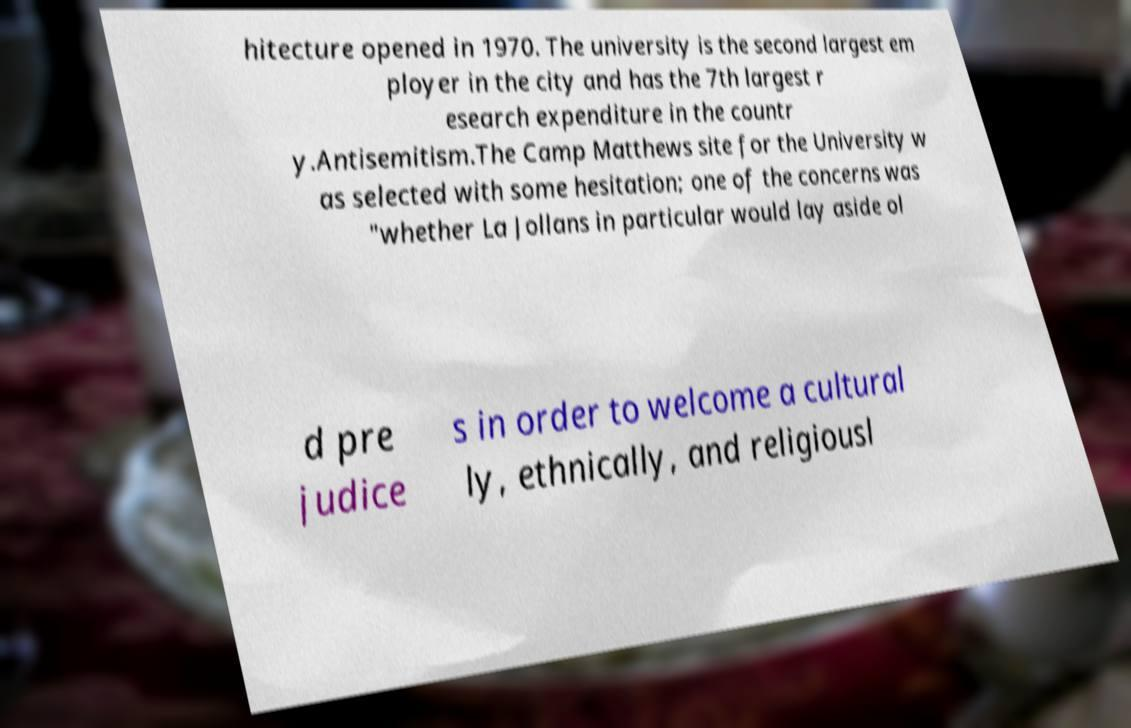What messages or text are displayed in this image? I need them in a readable, typed format. hitecture opened in 1970. The university is the second largest em ployer in the city and has the 7th largest r esearch expenditure in the countr y.Antisemitism.The Camp Matthews site for the University w as selected with some hesitation; one of the concerns was "whether La Jollans in particular would lay aside ol d pre judice s in order to welcome a cultural ly, ethnically, and religiousl 